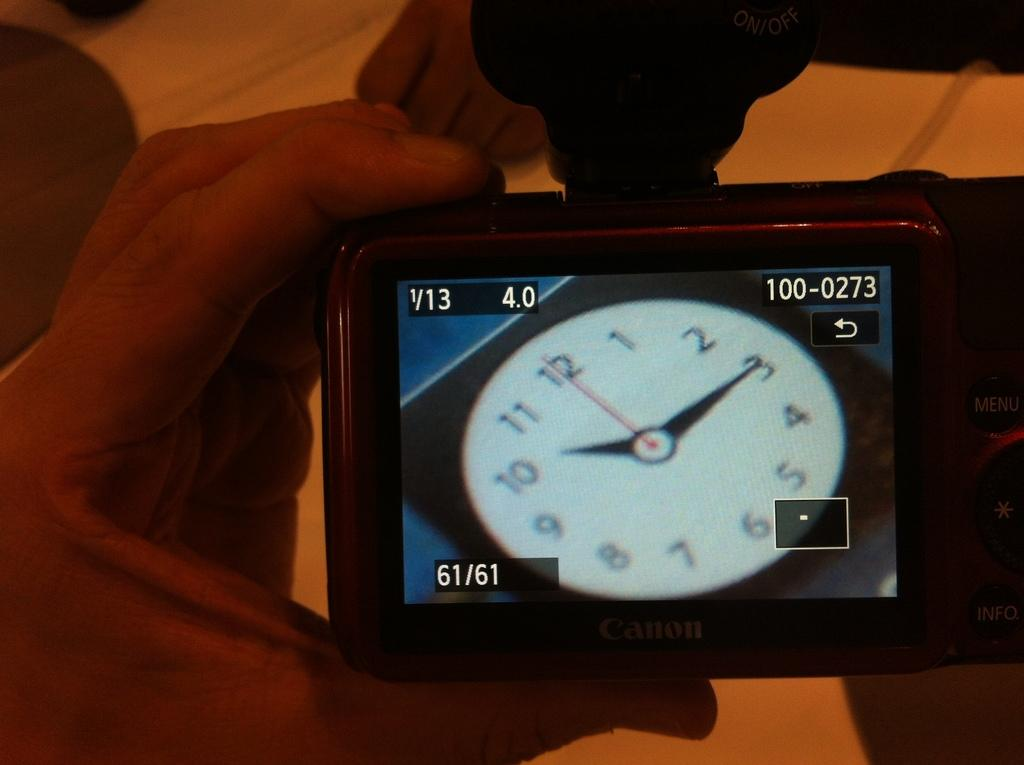What is the main subject of the image? There is a person in the image. What is the person holding in the image? The person is holding a camera. How many dolls are present in the image? There are no dolls present in the image; it features a person holding a camera. What is the person's need for the camera in the image? The image does not provide information about the person's need for the camera, so we cannot determine their motivation from the image alone. 